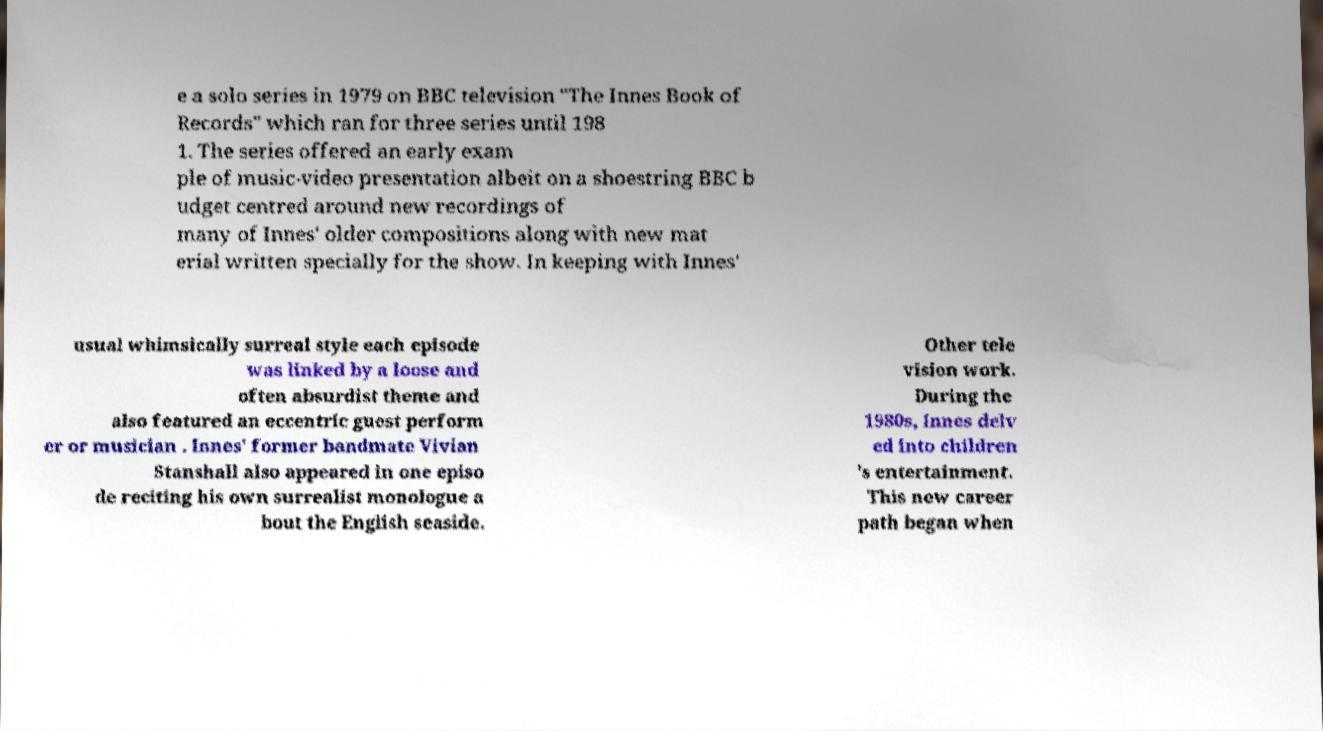There's text embedded in this image that I need extracted. Can you transcribe it verbatim? e a solo series in 1979 on BBC television "The Innes Book of Records" which ran for three series until 198 1. The series offered an early exam ple of music-video presentation albeit on a shoestring BBC b udget centred around new recordings of many of Innes' older compositions along with new mat erial written specially for the show. In keeping with Innes' usual whimsically surreal style each episode was linked by a loose and often absurdist theme and also featured an eccentric guest perform er or musician . Innes' former bandmate Vivian Stanshall also appeared in one episo de reciting his own surrealist monologue a bout the English seaside. Other tele vision work. During the 1980s, Innes delv ed into children 's entertainment. This new career path began when 